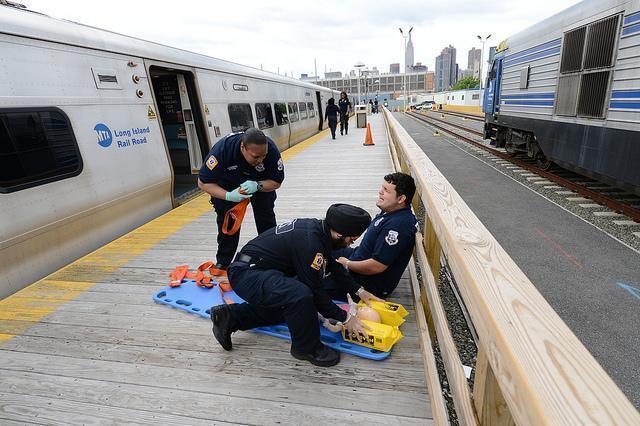Which major US city does this train line service?
From the following set of four choices, select the accurate answer to respond to the question.
Options: Philadelphia, new york, boston, washington d.c. New york. 